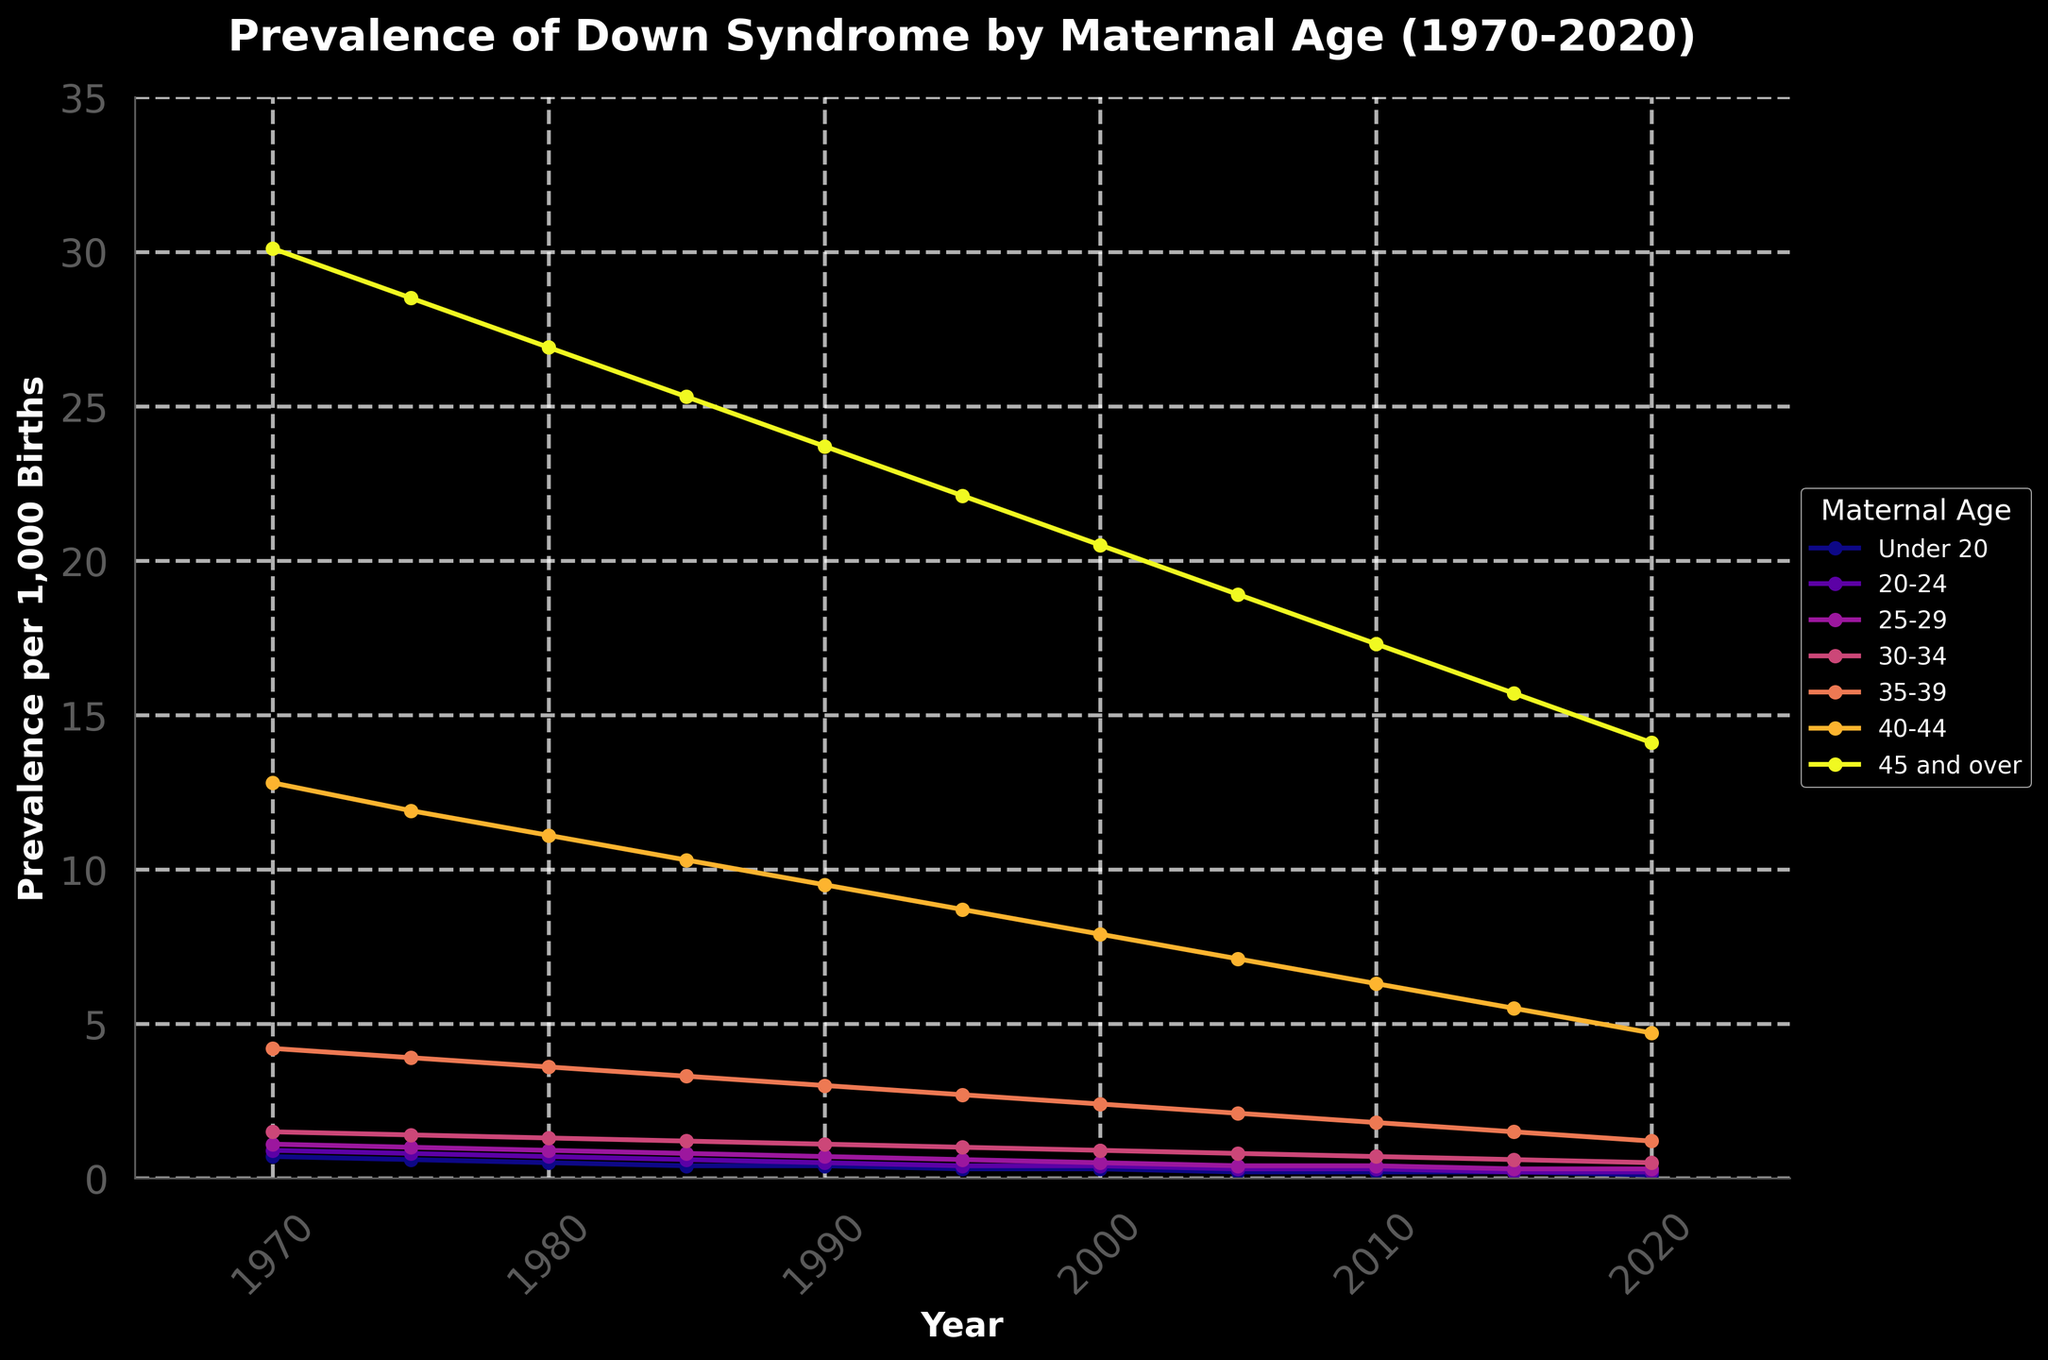What's the trend in Down syndrome prevalence amongst mothers aged 30-34 from 1970 to 2020? To identify the trend, observe the line representing the 30-34 age group from 1970 to 2020. The prevalence of Down syndrome decreases from approximately 1.5 per 1,000 births in 1970 to about 0.5 per 1,000 births in 2020.
Answer: Decreasing In which year did mothers aged 40-44 have a prevalence of 12.8 per 1,000 births for Down syndrome? Look for the line representing the 40-44 age group and check for the year where the prevalence is 12.8 per 1,000 births. In 1970, the prevalence in this age group is about 12.8 per 1,000 births.
Answer: 1970 How does the prevalence of Down syndrome in mothers aged under 20 compare between 1970 and 2020? For mothers under 20, the prevalence in 1970 is approximately 0.7 per 1,000 births, and in 2020, it is about 0.1 per 1,000 births. This shows the prevalence for this age group decreased over 50 years.
Answer: Decreased What is the difference in Down syndrome prevalence between mothers aged 25-29 and mothers aged 35-39 in the year 2020? In 2020, the prevalence for mothers aged 25-29 is about 0.3 per 1,000 births. For mothers aged 35-39, it is approximately 1.2 per 1,000 births. The difference is 1.2 - 0.3 = 0.9 per 1,000 births.
Answer: 0.9 In what year did the overall prevalence of Down syndrome in each maternal age group see the least difference compared to its previous value? Compare the prevalence values year-to-year for each age group, focusing on the minimal differences. For many age groups, between 1985 and 1990, the differences seem relatively small. For instance, mothers aged 45 and over have a prevalence difference of 1.6 (23.7 - 25.3) per 1,000 births.
Answer: 1985-1990 Which age group had the highest prevalence of Down syndrome in 2015? Inspect the prevalence values for each age group in 2015. The 45 and over age group has the highest prevalence at approximately 15.7 per 1,000 births.
Answer: 45 and over What maternal age group showed the steepest decline in prevalence from 1970 to 2020? Calculate the decline for each age group over the 50 years. The 40-44 age group declined from 12.8 to 4.7, which is a drop of 8.1 per 1,000 births. Other age groups show smaller declines.
Answer: 40-44 What is the combined prevalence of Down syndrome in mothers aged 25-29 and 30-34 in the year 1980? The prevalence for mothers aged 25-29 in 1980 is 0.9, and for mothers aged 30-34 is 1.3. Combine them by adding the values: 0.9 + 1.3 = 2.2 per 1,000 births.
Answer: 2.2 